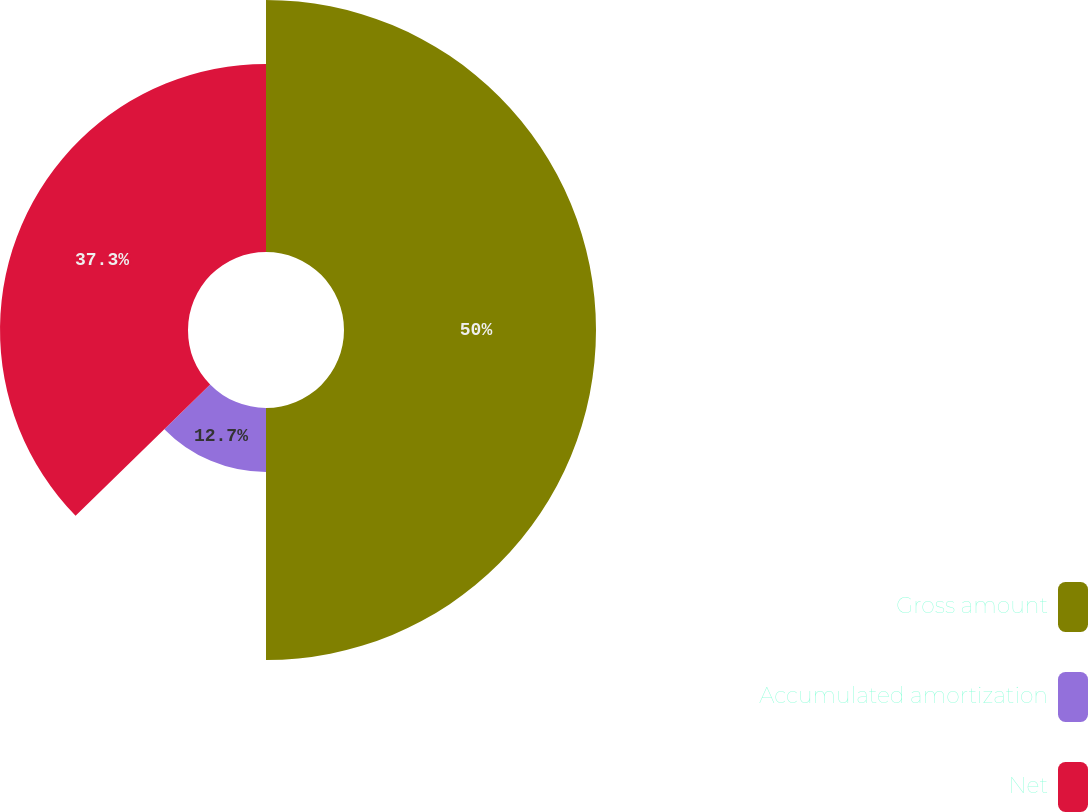Convert chart. <chart><loc_0><loc_0><loc_500><loc_500><pie_chart><fcel>Gross amount<fcel>Accumulated amortization<fcel>Net<nl><fcel>50.0%<fcel>12.7%<fcel>37.3%<nl></chart> 